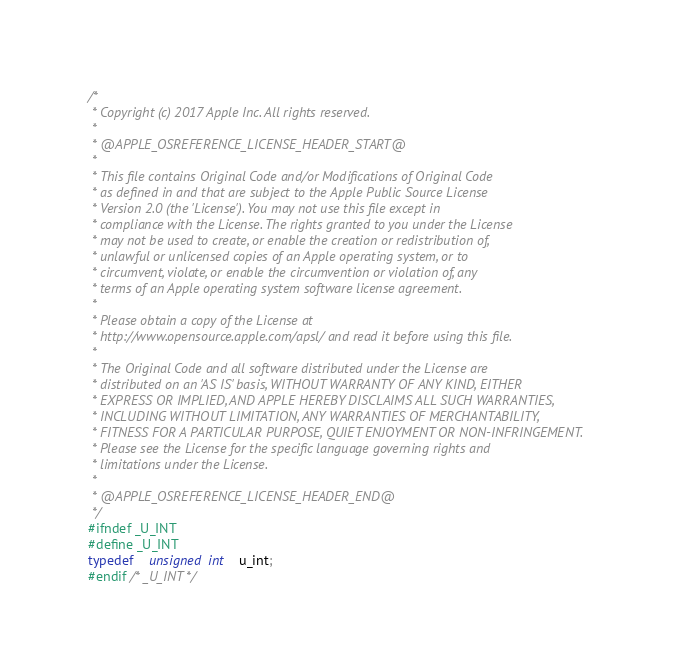Convert code to text. <code><loc_0><loc_0><loc_500><loc_500><_C_>/*
 * Copyright (c) 2017 Apple Inc. All rights reserved.
 *
 * @APPLE_OSREFERENCE_LICENSE_HEADER_START@
 * 
 * This file contains Original Code and/or Modifications of Original Code
 * as defined in and that are subject to the Apple Public Source License
 * Version 2.0 (the 'License'). You may not use this file except in
 * compliance with the License. The rights granted to you under the License
 * may not be used to create, or enable the creation or redistribution of,
 * unlawful or unlicensed copies of an Apple operating system, or to
 * circumvent, violate, or enable the circumvention or violation of, any
 * terms of an Apple operating system software license agreement.
 * 
 * Please obtain a copy of the License at
 * http://www.opensource.apple.com/apsl/ and read it before using this file.
 * 
 * The Original Code and all software distributed under the License are
 * distributed on an 'AS IS' basis, WITHOUT WARRANTY OF ANY KIND, EITHER
 * EXPRESS OR IMPLIED, AND APPLE HEREBY DISCLAIMS ALL SUCH WARRANTIES,
 * INCLUDING WITHOUT LIMITATION, ANY WARRANTIES OF MERCHANTABILITY,
 * FITNESS FOR A PARTICULAR PURPOSE, QUIET ENJOYMENT OR NON-INFRINGEMENT.
 * Please see the License for the specific language governing rights and
 * limitations under the License.
 * 
 * @APPLE_OSREFERENCE_LICENSE_HEADER_END@
 */
#ifndef _U_INT
#define _U_INT
typedef	unsigned int 	u_int;
#endif /* _U_INT */
</code> 